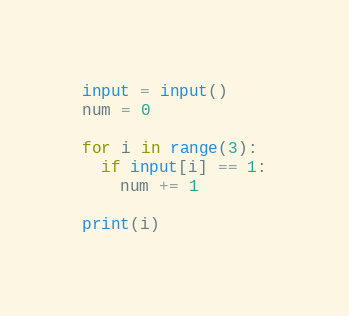<code> <loc_0><loc_0><loc_500><loc_500><_Python_>input = input()
num = 0

for i in range(3):
  if input[i] == 1:
    num += 1

print(i)
</code> 